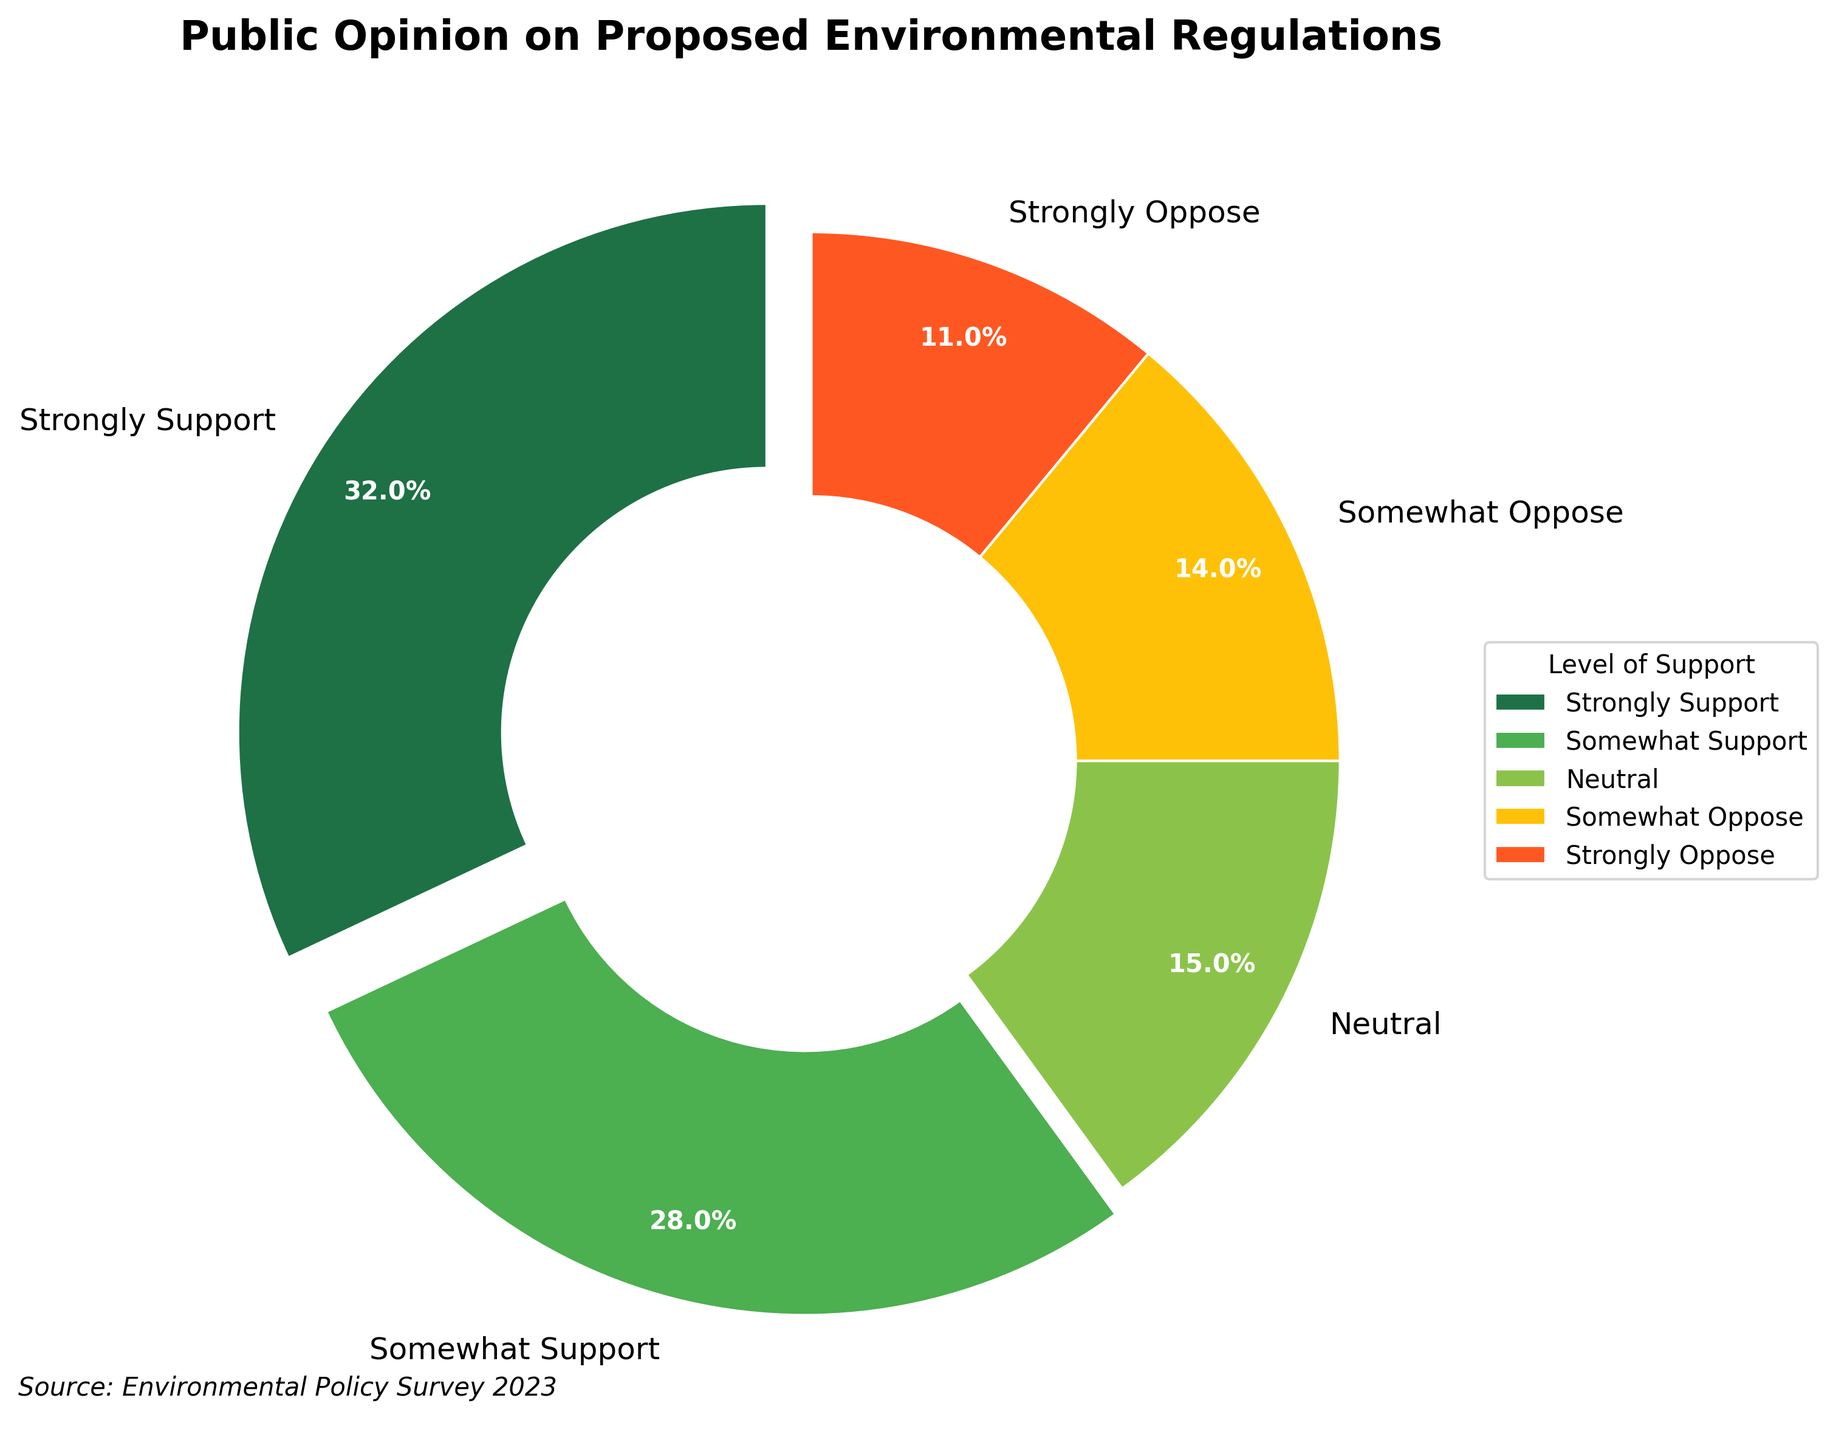Which level of support is the most prevalent? The "Strongly Support" section is the largest piece of the pie chart, indicating it has the highest percentage.
Answer: Strongly Support What is the combined percentage of people who are either neutral or somewhat oppose the regulations? Summing the percentages for "Neutral" and "Somewhat Oppose": 15% + 14% = 29%.
Answer: 29% Which color represents the group with the least support? The smallest segment is "Strongly Oppose" which is represented in red.
Answer: Red How much larger is the percentage of people who strongly support compared to those who strongly oppose? The percentage for "Strongly Support" is 32% and for "Strongly Oppose" is 11%. The difference is 32% - 11% = 21%.
Answer: 21% What percentage of respondents are somewhat supportive? The segment labeled "Somewhat Support" has a percentage of 28%.
Answer: 28% If the percentages for "Somewhat Oppose" and "Strongly Oppose" are combined, how do they compare to the percentage of "Strongly Support"? Summing "Somewhat Oppose" and "Strongly Oppose" gives 14% + 11% = 25%. This is less than the "Strongly Support" group's 32%.
Answer: Less Which portion of the chart is colored green and what is its percentage? The green portion represents "Somewhat Support" with a percentage of 28%.
Answer: Somewhat Support, 28% Is the percentage of neutral responses higher or lower than the percentage of those who somewhat oppose? The percentage for "Neutral" is 15%, while for "Somewhat Oppose" it is 14%. Therefore, neutral responses are higher.
Answer: Higher What is the aggregate percentage of respondents who are in favor of the regulations (strongly or somewhat)? Adding the percentages for "Strongly Support" and "Somewhat Support": 32% + 28% = 60%.
Answer: 60% Which segments of the pie chart use shades of green? "Strongly Support" and "Somewhat Support" segments are shaded in different shades of green.
Answer: Strongly Support, Somewhat Support 